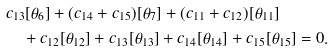<formula> <loc_0><loc_0><loc_500><loc_500>& c _ { 1 3 } [ \theta _ { 6 } ] + ( c _ { 1 4 } + c _ { 1 5 } ) [ \theta _ { 7 } ] + ( c _ { 1 1 } + c _ { 1 2 } ) [ \theta _ { 1 1 } ] \\ & \quad + c _ { 1 2 } [ \theta _ { 1 2 } ] + c _ { 1 3 } [ \theta _ { 1 3 } ] + c _ { 1 4 } [ \theta _ { 1 4 } ] + c _ { 1 5 } [ \theta _ { 1 5 } ] = 0 .</formula> 